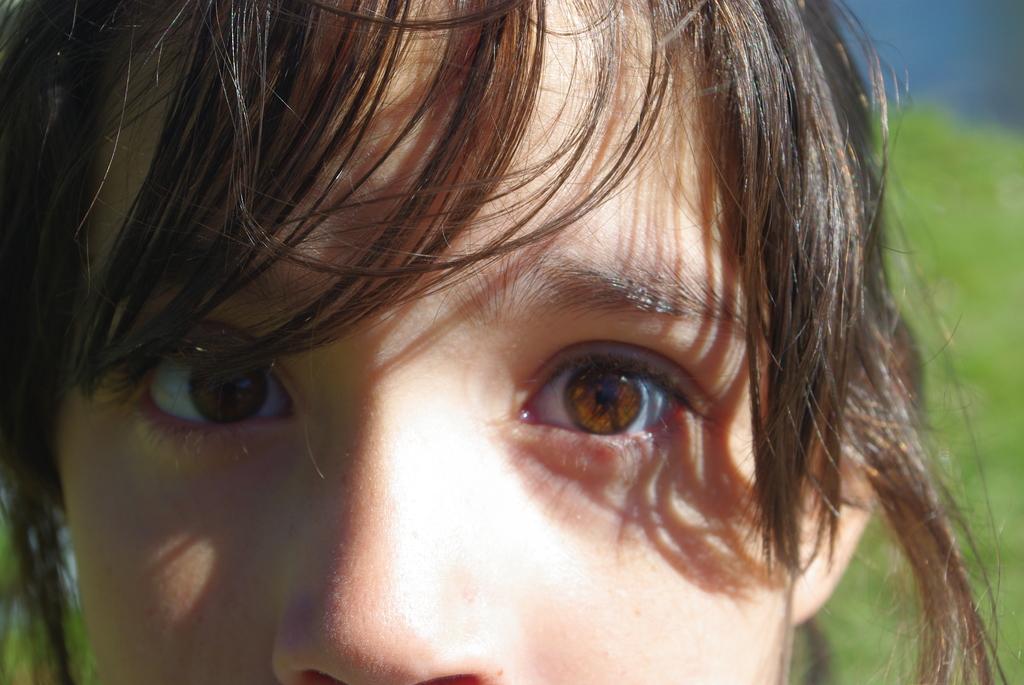Please provide a concise description of this image. In this image I can see a person's face. The background of the image is blurred. 